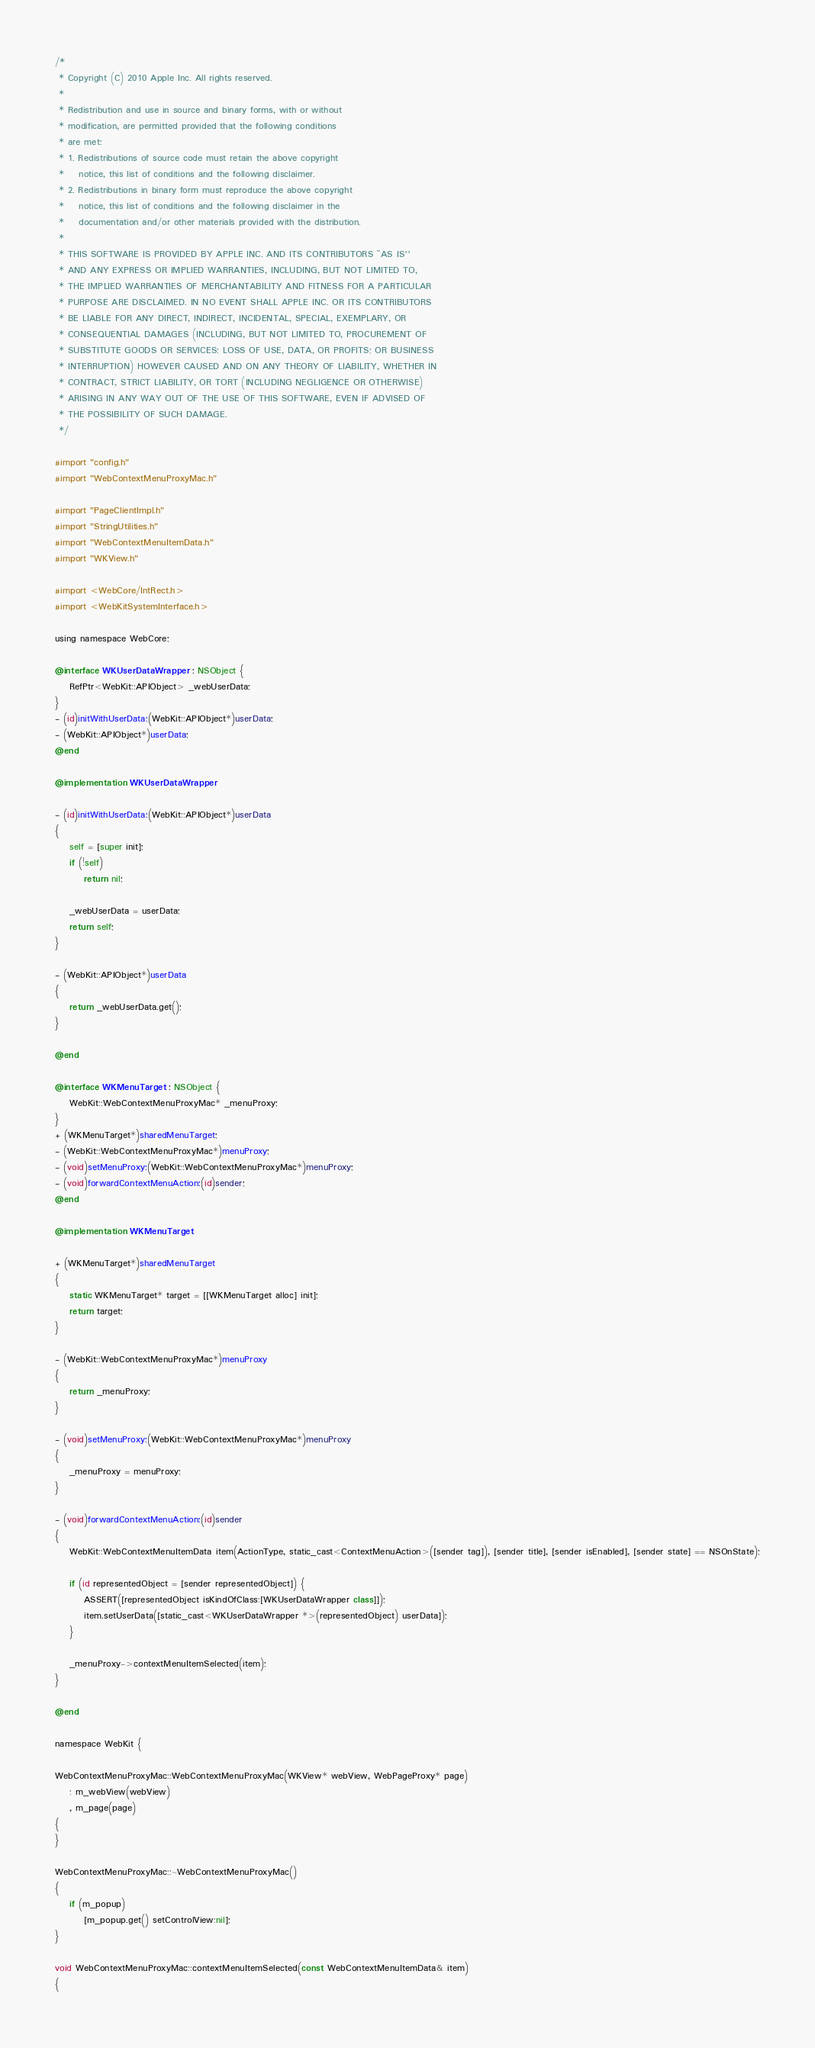Convert code to text. <code><loc_0><loc_0><loc_500><loc_500><_ObjectiveC_>/*
 * Copyright (C) 2010 Apple Inc. All rights reserved.
 *
 * Redistribution and use in source and binary forms, with or without
 * modification, are permitted provided that the following conditions
 * are met:
 * 1. Redistributions of source code must retain the above copyright
 *    notice, this list of conditions and the following disclaimer.
 * 2. Redistributions in binary form must reproduce the above copyright
 *    notice, this list of conditions and the following disclaimer in the
 *    documentation and/or other materials provided with the distribution.
 *
 * THIS SOFTWARE IS PROVIDED BY APPLE INC. AND ITS CONTRIBUTORS ``AS IS''
 * AND ANY EXPRESS OR IMPLIED WARRANTIES, INCLUDING, BUT NOT LIMITED TO,
 * THE IMPLIED WARRANTIES OF MERCHANTABILITY AND FITNESS FOR A PARTICULAR
 * PURPOSE ARE DISCLAIMED. IN NO EVENT SHALL APPLE INC. OR ITS CONTRIBUTORS
 * BE LIABLE FOR ANY DIRECT, INDIRECT, INCIDENTAL, SPECIAL, EXEMPLARY, OR
 * CONSEQUENTIAL DAMAGES (INCLUDING, BUT NOT LIMITED TO, PROCUREMENT OF
 * SUBSTITUTE GOODS OR SERVICES; LOSS OF USE, DATA, OR PROFITS; OR BUSINESS
 * INTERRUPTION) HOWEVER CAUSED AND ON ANY THEORY OF LIABILITY, WHETHER IN
 * CONTRACT, STRICT LIABILITY, OR TORT (INCLUDING NEGLIGENCE OR OTHERWISE)
 * ARISING IN ANY WAY OUT OF THE USE OF THIS SOFTWARE, EVEN IF ADVISED OF
 * THE POSSIBILITY OF SUCH DAMAGE.
 */

#import "config.h"
#import "WebContextMenuProxyMac.h"

#import "PageClientImpl.h"
#import "StringUtilities.h"
#import "WebContextMenuItemData.h"
#import "WKView.h"

#import <WebCore/IntRect.h>
#import <WebKitSystemInterface.h>

using namespace WebCore;

@interface WKUserDataWrapper : NSObject {
    RefPtr<WebKit::APIObject> _webUserData;
}
- (id)initWithUserData:(WebKit::APIObject*)userData;
- (WebKit::APIObject*)userData;
@end

@implementation WKUserDataWrapper

- (id)initWithUserData:(WebKit::APIObject*)userData
{
    self = [super init];
    if (!self)
        return nil;
    
    _webUserData = userData;
    return self;
}

- (WebKit::APIObject*)userData
{
    return _webUserData.get();
}

@end

@interface WKMenuTarget : NSObject {
    WebKit::WebContextMenuProxyMac* _menuProxy;
}
+ (WKMenuTarget*)sharedMenuTarget;
- (WebKit::WebContextMenuProxyMac*)menuProxy;
- (void)setMenuProxy:(WebKit::WebContextMenuProxyMac*)menuProxy;
- (void)forwardContextMenuAction:(id)sender;
@end

@implementation WKMenuTarget

+ (WKMenuTarget*)sharedMenuTarget
{
    static WKMenuTarget* target = [[WKMenuTarget alloc] init];
    return target;
}

- (WebKit::WebContextMenuProxyMac*)menuProxy
{
    return _menuProxy;
}

- (void)setMenuProxy:(WebKit::WebContextMenuProxyMac*)menuProxy
{
    _menuProxy = menuProxy;
}

- (void)forwardContextMenuAction:(id)sender
{
    WebKit::WebContextMenuItemData item(ActionType, static_cast<ContextMenuAction>([sender tag]), [sender title], [sender isEnabled], [sender state] == NSOnState);
    
    if (id representedObject = [sender representedObject]) {
        ASSERT([representedObject isKindOfClass:[WKUserDataWrapper class]]);
        item.setUserData([static_cast<WKUserDataWrapper *>(representedObject) userData]);
    }
            
    _menuProxy->contextMenuItemSelected(item);
}

@end

namespace WebKit {

WebContextMenuProxyMac::WebContextMenuProxyMac(WKView* webView, WebPageProxy* page)
    : m_webView(webView)
    , m_page(page)
{
}

WebContextMenuProxyMac::~WebContextMenuProxyMac()
{
    if (m_popup)
        [m_popup.get() setControlView:nil];
}

void WebContextMenuProxyMac::contextMenuItemSelected(const WebContextMenuItemData& item)
{</code> 